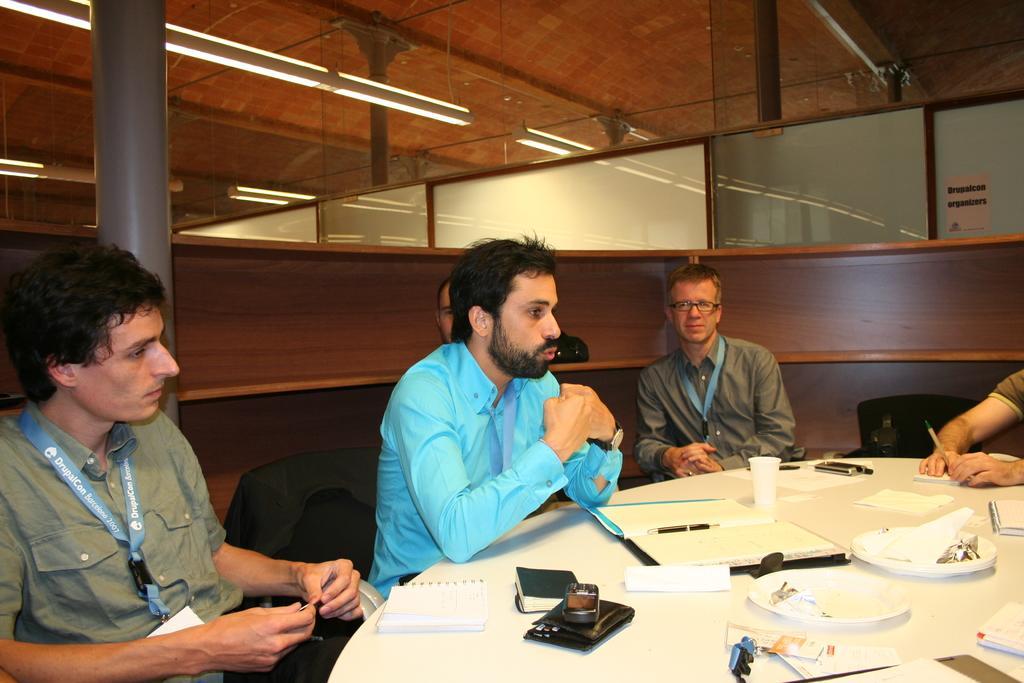Describe this image in one or two sentences. This picture is of inside. On the right corner there is a table on the top of which books, pen, glass and plates are placed. On the right corner there is a man seems to be sitting. In the center there is a man wearing blue color shirt, sitting on the chair and talking, beside him there is a man wearing spectacles and sitting on the chair. On the left corner we can see a man sitting on the chair. In the background we can see a pillar and windows. 